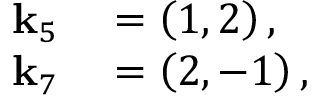<formula> <loc_0><loc_0><loc_500><loc_500>\begin{array} { r l } { k _ { 5 } } & = \left ( 1 , 2 \right ) , } \\ { k _ { 7 } } & = \left ( 2 , - 1 \right ) , } \end{array}</formula> 